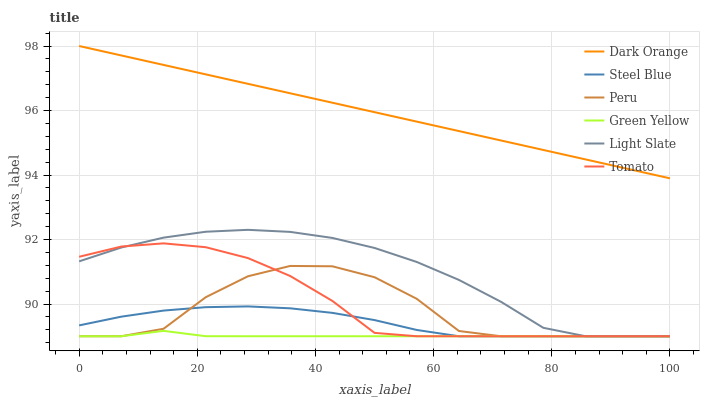Does Green Yellow have the minimum area under the curve?
Answer yes or no. Yes. Does Dark Orange have the maximum area under the curve?
Answer yes or no. Yes. Does Light Slate have the minimum area under the curve?
Answer yes or no. No. Does Light Slate have the maximum area under the curve?
Answer yes or no. No. Is Dark Orange the smoothest?
Answer yes or no. Yes. Is Peru the roughest?
Answer yes or no. Yes. Is Light Slate the smoothest?
Answer yes or no. No. Is Light Slate the roughest?
Answer yes or no. No. Does Tomato have the lowest value?
Answer yes or no. Yes. Does Dark Orange have the lowest value?
Answer yes or no. No. Does Dark Orange have the highest value?
Answer yes or no. Yes. Does Light Slate have the highest value?
Answer yes or no. No. Is Green Yellow less than Dark Orange?
Answer yes or no. Yes. Is Dark Orange greater than Green Yellow?
Answer yes or no. Yes. Does Peru intersect Light Slate?
Answer yes or no. Yes. Is Peru less than Light Slate?
Answer yes or no. No. Is Peru greater than Light Slate?
Answer yes or no. No. Does Green Yellow intersect Dark Orange?
Answer yes or no. No. 